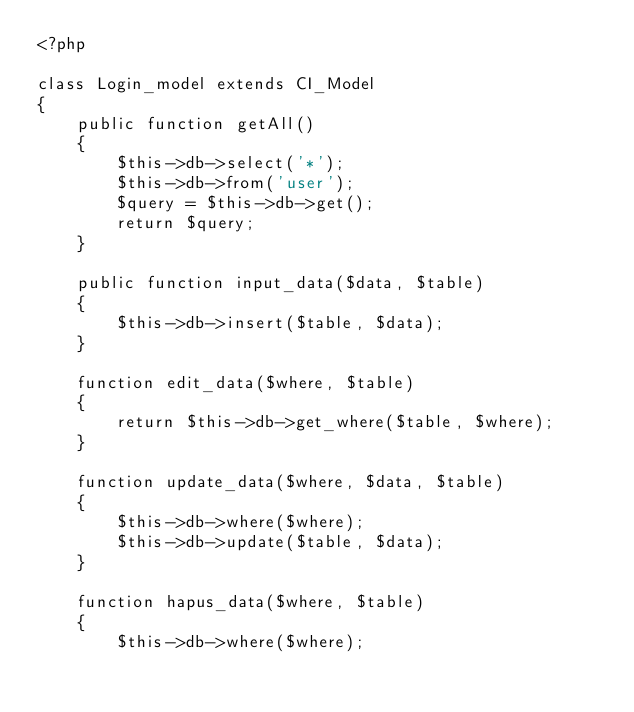<code> <loc_0><loc_0><loc_500><loc_500><_PHP_><?php

class Login_model extends CI_Model
{
    public function getAll()
    {
        $this->db->select('*');
        $this->db->from('user');
        $query = $this->db->get();
        return $query;
    }

    public function input_data($data, $table)
    {
        $this->db->insert($table, $data);
    }

    function edit_data($where, $table)
    {
        return $this->db->get_where($table, $where);
    }

    function update_data($where, $data, $table)
    {
        $this->db->where($where);
        $this->db->update($table, $data);
    }

    function hapus_data($where, $table)
    {
        $this->db->where($where);</code> 